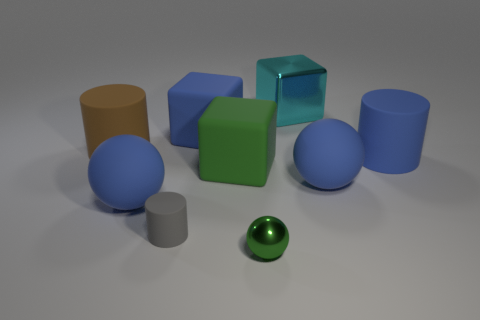There is a matte cube in front of the brown cylinder; is it the same color as the small shiny thing?
Offer a very short reply. Yes. Is there a big matte cube of the same color as the metal ball?
Ensure brevity in your answer.  Yes. There is a green metallic thing; how many cyan blocks are in front of it?
Offer a very short reply. 0. How many other things are there of the same size as the blue cube?
Keep it short and to the point. 6. Do the large cylinder that is left of the gray matte object and the large ball that is left of the small green object have the same material?
Keep it short and to the point. Yes. What color is the ball that is the same size as the gray object?
Provide a short and direct response. Green. Is there any other thing that has the same color as the small rubber cylinder?
Your answer should be compact. No. How big is the matte cylinder that is in front of the blue rubber ball to the left of the blue rubber ball that is right of the gray thing?
Your answer should be compact. Small. What is the color of the object that is to the left of the small gray cylinder and in front of the big blue matte cylinder?
Your response must be concise. Blue. What size is the matte sphere on the right side of the small green shiny sphere?
Your answer should be very brief. Large. 